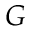<formula> <loc_0><loc_0><loc_500><loc_500>G</formula> 